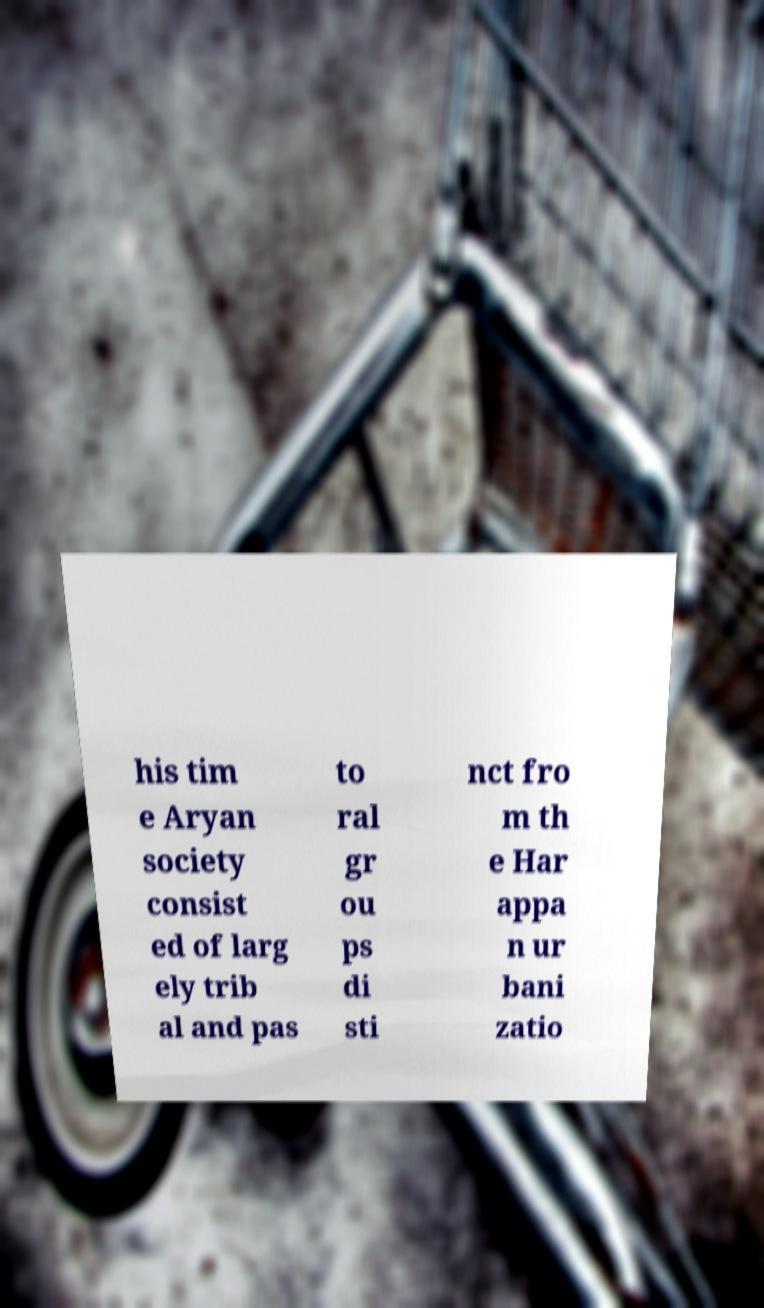There's text embedded in this image that I need extracted. Can you transcribe it verbatim? his tim e Aryan society consist ed of larg ely trib al and pas to ral gr ou ps di sti nct fro m th e Har appa n ur bani zatio 